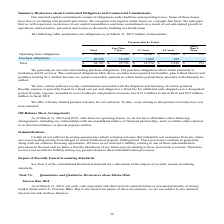According to Commvault Systems's financial document, What kinds of purchase obligations does the data refer to? Based on the financial document, the answer is primarily to marketing and IT services. Also, How much was the royalty expense in fiscal 2019 and fiscal 2018 respectively? The document shows two values: $12.3 million and $4.5 million (in millions). From the document: "ucts revenues was $12.3 million in fiscal 2019 and $4.5 million million in fiscal 2018. uded in cost of software and products revenues was $12.3 milli..." Also, How long is the product warranty period for the company's software? According to the financial document, 90-day. The relevant text states: "We offer a 90-day limited product warranty for our software. To date, costs relating to this product warranty have no..." Also, can you calculate: What is the amount of purchase obligations due in the next 3 years? Based on the calculation: 16,748+3,669, the result is 20417 (in thousands). This is based on the information: "Purchase obligations 20,520 16,748 3,669 103 — Purchase obligations 20,520 16,748 3,669 103 —..." The key data points involved are: 16,748, 3,669. Also, can you calculate: What percentage of operating lease obligations are due in more than 4 years? To answer this question, I need to perform calculations using the financial data. The calculation is: (931+2,827)/23,673, which equals 0.16 (percentage). This is based on the information: "ing lease obligations $ 23,673 $ 9,008 $ 10,907 $ 2,827 $ 931 Operating lease obligations $ 23,673 $ 9,008 $ 10,907 $ 2,827 $ 931 e obligations $ 23,673 $ 9,008 $ 10,907 $ 2,827 $ 931..." The key data points involved are: 2,827, 23,673, 931. Also, can you calculate: How much less operating lease obligations than purchase obligations does the company have due in less than 1 year? Based on the calculation: 16,748-9,008, the result is 7740 (in thousands). This is based on the information: "Operating lease obligations $ 23,673 $ 9,008 $ 10,907 $ 2,827 $ 931 Purchase obligations 20,520 16,748 3,669 103 —..." The key data points involved are: 16,748, 9,008. 